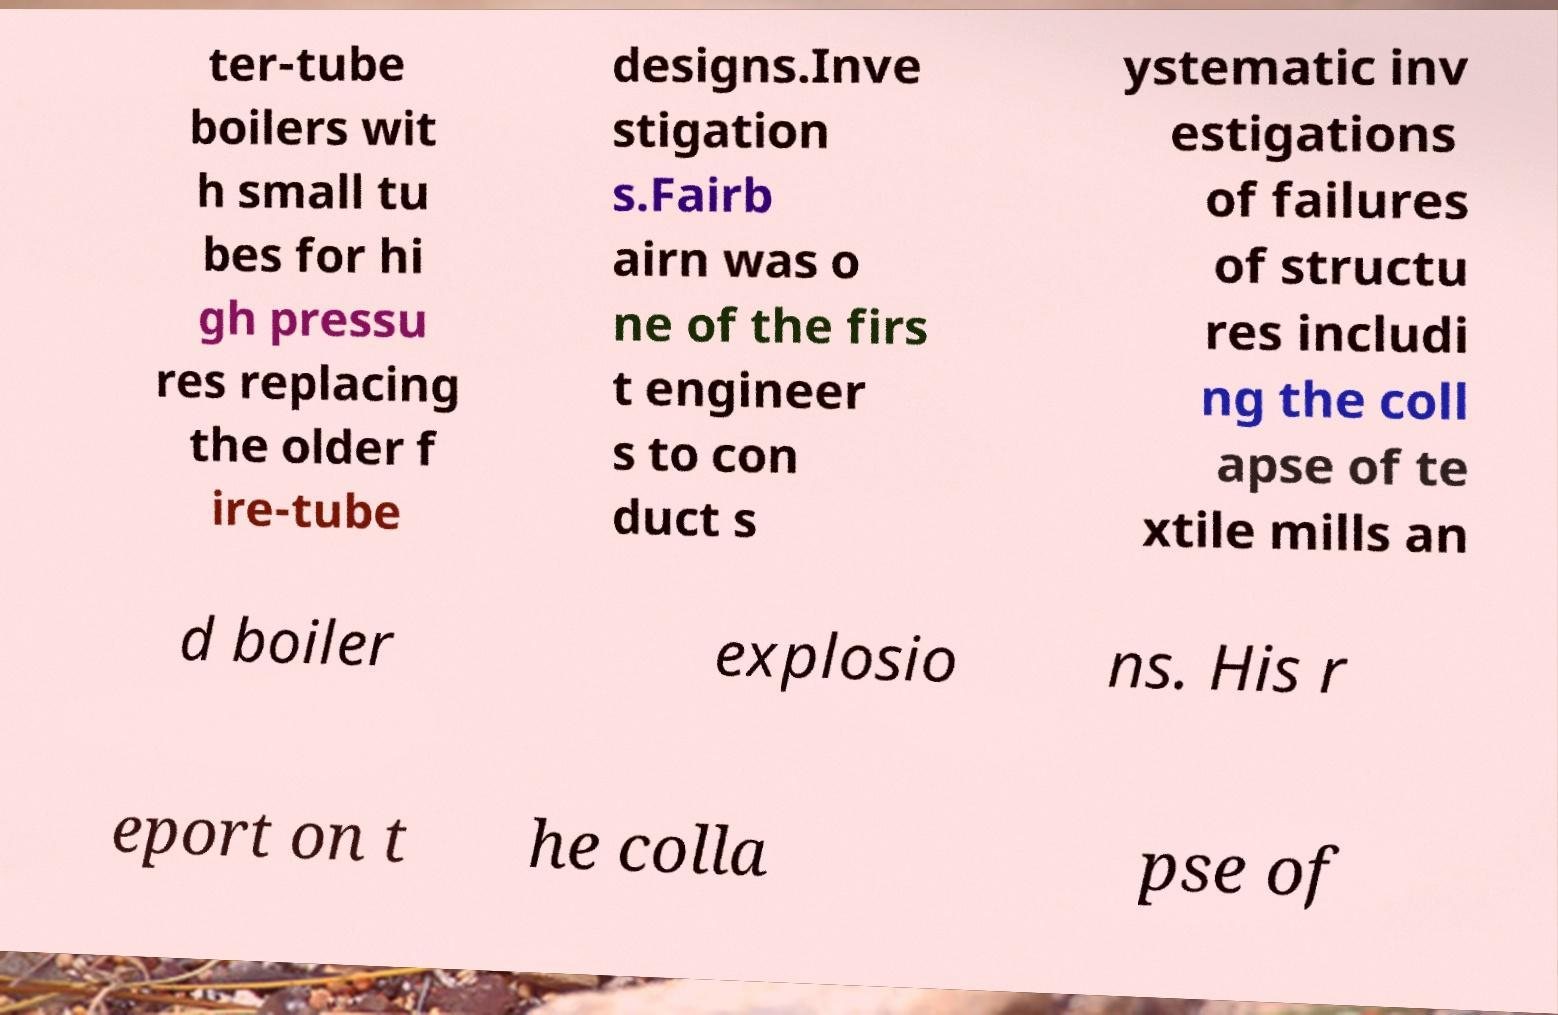What messages or text are displayed in this image? I need them in a readable, typed format. ter-tube boilers wit h small tu bes for hi gh pressu res replacing the older f ire-tube designs.Inve stigation s.Fairb airn was o ne of the firs t engineer s to con duct s ystematic inv estigations of failures of structu res includi ng the coll apse of te xtile mills an d boiler explosio ns. His r eport on t he colla pse of 